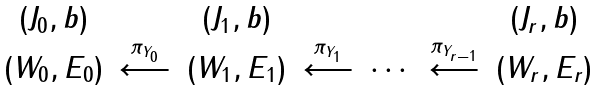<formula> <loc_0><loc_0><loc_500><loc_500>\begin{array} { c c c c c c c c } ( J _ { 0 } , b ) & & ( J _ { 1 } , b ) & & & & ( J _ { r } , b ) \\ ( W _ { 0 } , E _ { 0 } ) & \overset { \pi _ { Y _ { 0 } } } { \longleftarrow } & ( W _ { 1 } , E _ { 1 } ) & \overset { \pi _ { Y _ { 1 } } } { \longleftarrow } & \cdots & \overset { \pi _ { Y _ { r - 1 } } } { \longleftarrow } & ( W _ { r } , E _ { r } ) \end{array}</formula> 